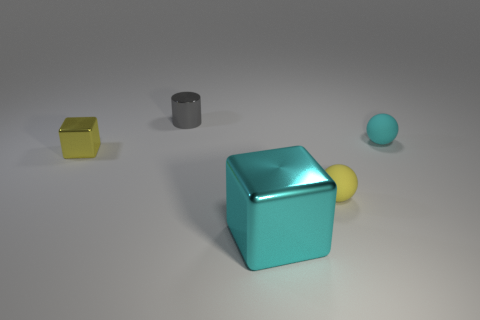What is the yellow thing that is right of the tiny cylinder made of?
Your answer should be very brief. Rubber. What number of big objects are either cyan matte things or purple blocks?
Make the answer very short. 0. What is the material of the sphere that is the same color as the big metallic thing?
Make the answer very short. Rubber. Is there a large thing made of the same material as the yellow cube?
Make the answer very short. Yes. Does the block to the left of the gray object have the same size as the gray shiny thing?
Give a very brief answer. Yes. There is a metallic thing that is in front of the small object on the left side of the gray cylinder; are there any small gray cylinders that are in front of it?
Ensure brevity in your answer.  No. What number of metal objects are large things or tiny green balls?
Keep it short and to the point. 1. How many other objects are the same shape as the small gray metallic object?
Your answer should be compact. 0. Are there more tiny yellow metallic blocks than green matte cylinders?
Provide a short and direct response. Yes. There is a ball in front of the tiny rubber object behind the tiny yellow object that is in front of the small yellow metal block; what is its size?
Keep it short and to the point. Small. 